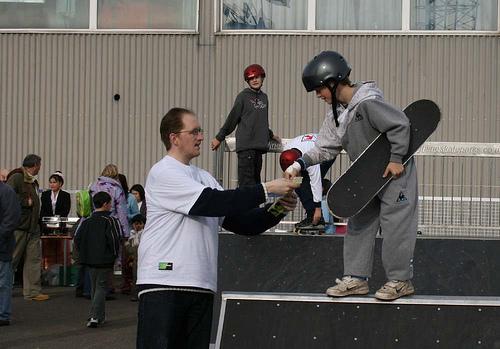What is the boy holding?
Answer briefly. Skateboard. Is this a standard business handshake?
Give a very brief answer. No. What are the people wearing helmets for?
Keep it brief. Skateboarding. How many people are wearing helmets?
Concise answer only. 3. 